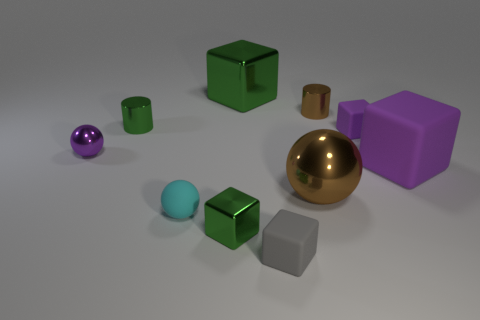Are there any matte objects that have the same size as the brown metal sphere? While it's difficult to discern size with complete accuracy from this image alone, the purple cube appears to have similar dimensions to the brown metal sphere, but please note that appearances can be deceptive without exact measurement instruments. 